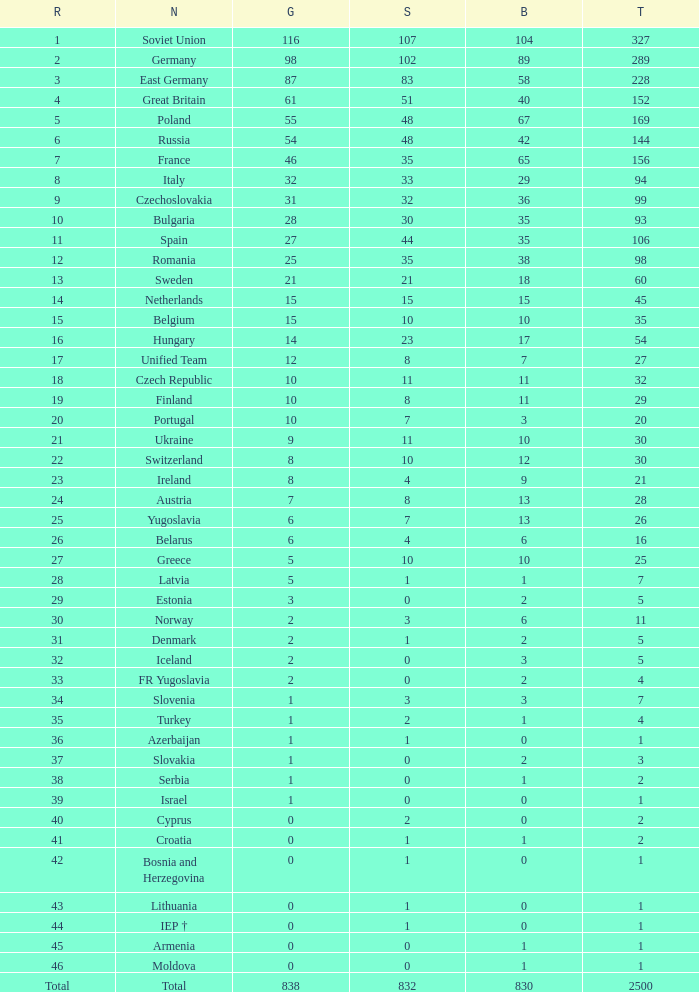What is the rank of the nation with more than 0 silver medals and 38 bronze medals? 12.0. 